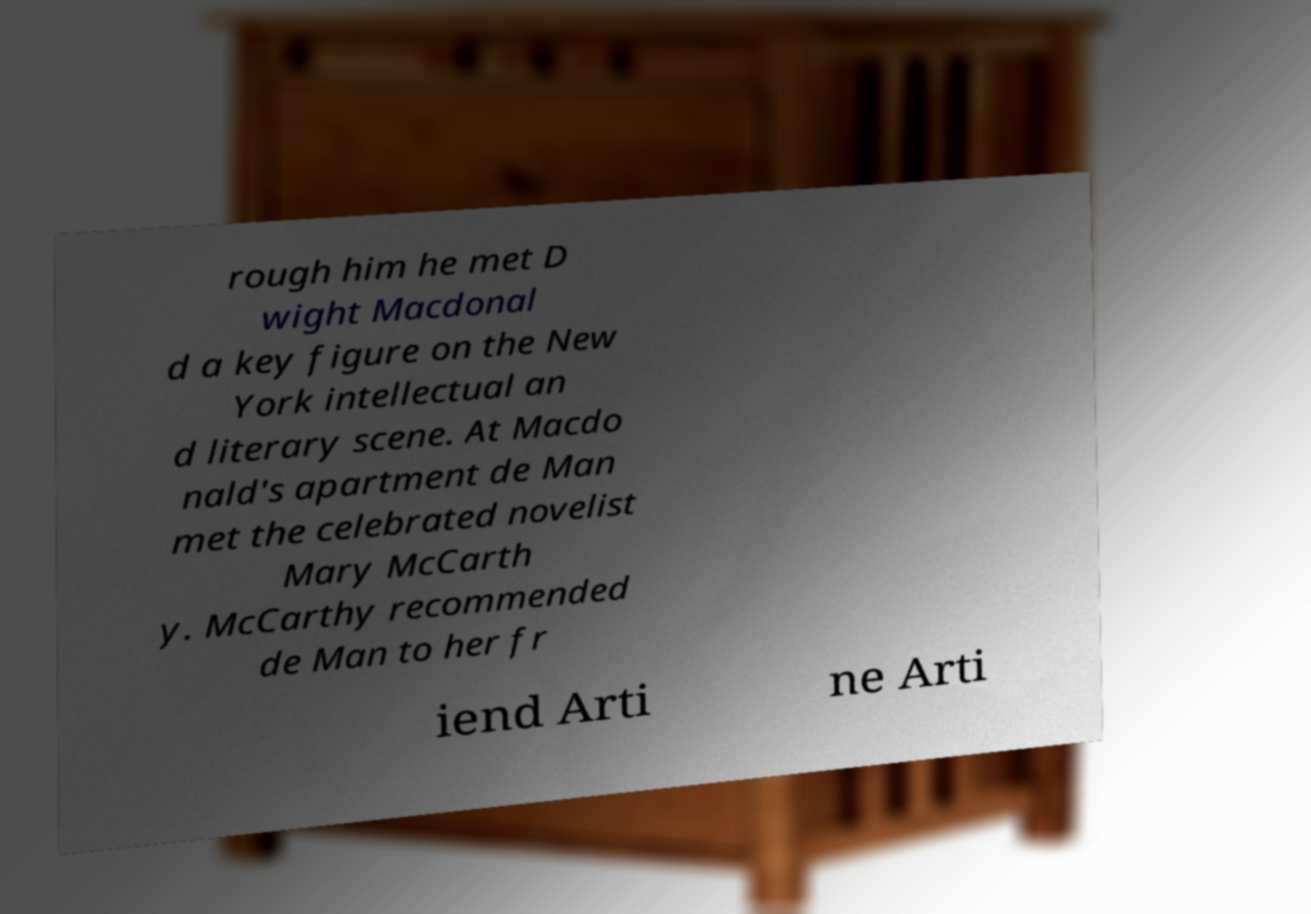Could you extract and type out the text from this image? rough him he met D wight Macdonal d a key figure on the New York intellectual an d literary scene. At Macdo nald's apartment de Man met the celebrated novelist Mary McCarth y. McCarthy recommended de Man to her fr iend Arti ne Arti 